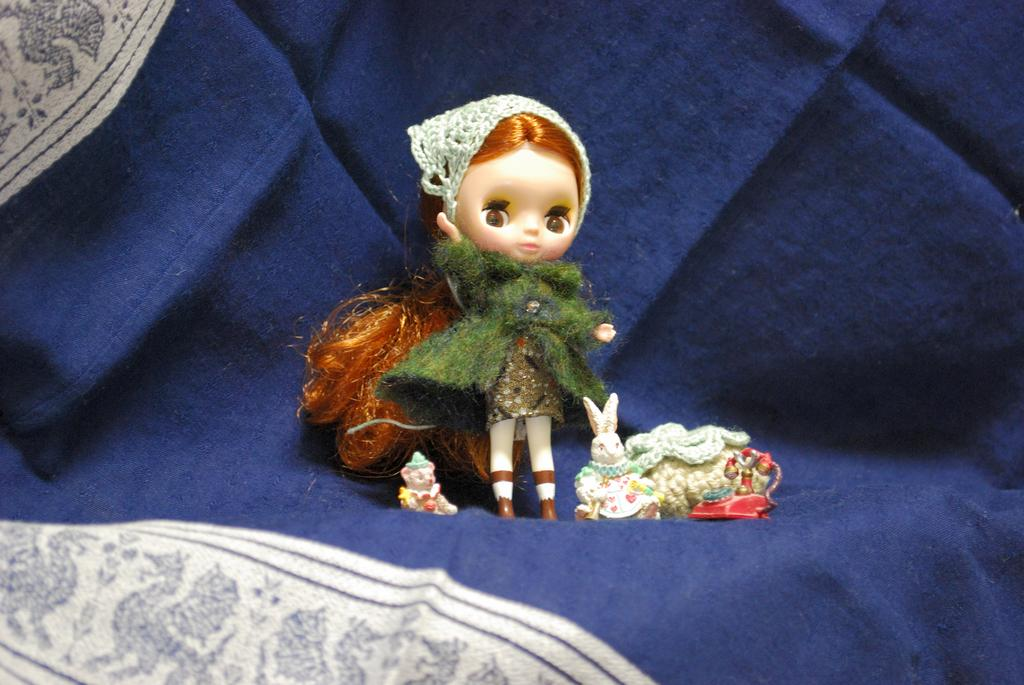What color is the cloth that is visible in the image? There is a blue cloth in the image. How is the blue cloth positioned in the image? The blue cloth is on a roll. What other items can be seen on the surface in the image? There are toys on the surface in the image. What type of knowledge can be gained from the harbor in the image? There is no harbor present in the image, so no knowledge can be gained from it. How many trucks are visible in the image? There are no trucks present in the image. 